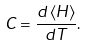Convert formula to latex. <formula><loc_0><loc_0><loc_500><loc_500>C = \frac { d \left \langle H \right \rangle } { d T } .</formula> 